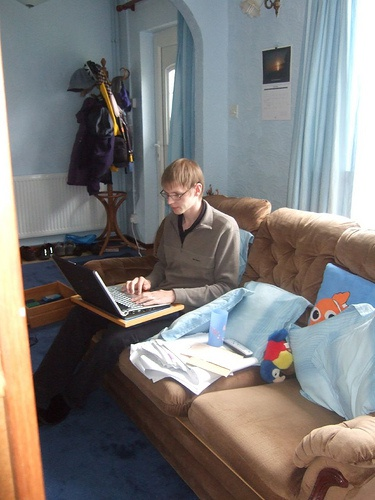Describe the objects in this image and their specific colors. I can see couch in gray, maroon, and brown tones, people in gray and black tones, laptop in gray, black, lightgray, and darkgray tones, cup in gray and lightblue tones, and remote in gray, lightgray, and darkgray tones in this image. 